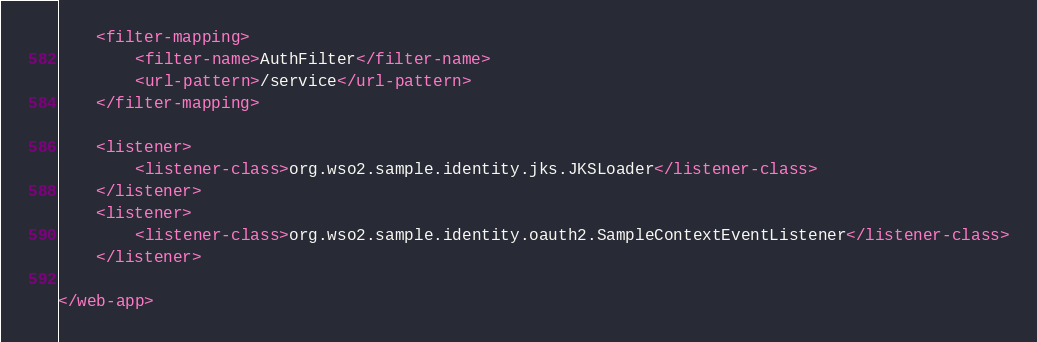<code> <loc_0><loc_0><loc_500><loc_500><_XML_>
    <filter-mapping>
        <filter-name>AuthFilter</filter-name>
        <url-pattern>/service</url-pattern>
    </filter-mapping>

    <listener>
        <listener-class>org.wso2.sample.identity.jks.JKSLoader</listener-class>
    </listener>
    <listener>
        <listener-class>org.wso2.sample.identity.oauth2.SampleContextEventListener</listener-class>
    </listener>

</web-app>
</code> 